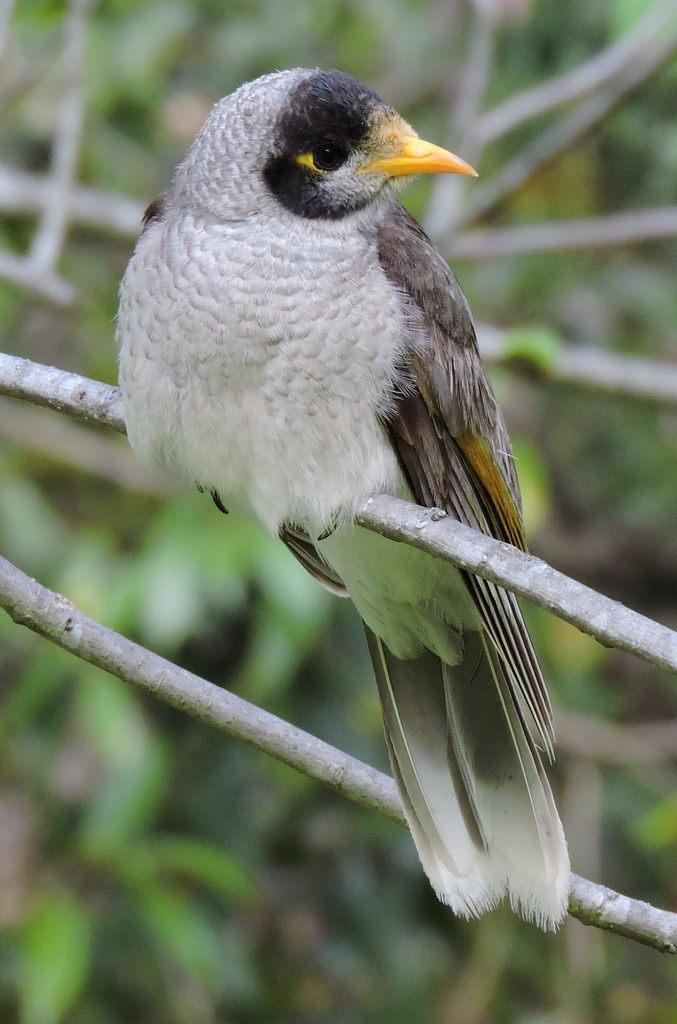Please provide a concise description of this image. In this picture, there is a bird standing on a tree. It is in white and brown in color. In the background, there are trees. 